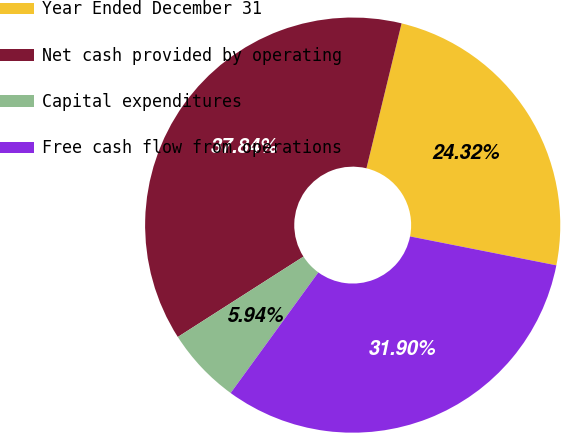<chart> <loc_0><loc_0><loc_500><loc_500><pie_chart><fcel>Year Ended December 31<fcel>Net cash provided by operating<fcel>Capital expenditures<fcel>Free cash flow from operations<nl><fcel>24.32%<fcel>37.84%<fcel>5.94%<fcel>31.9%<nl></chart> 